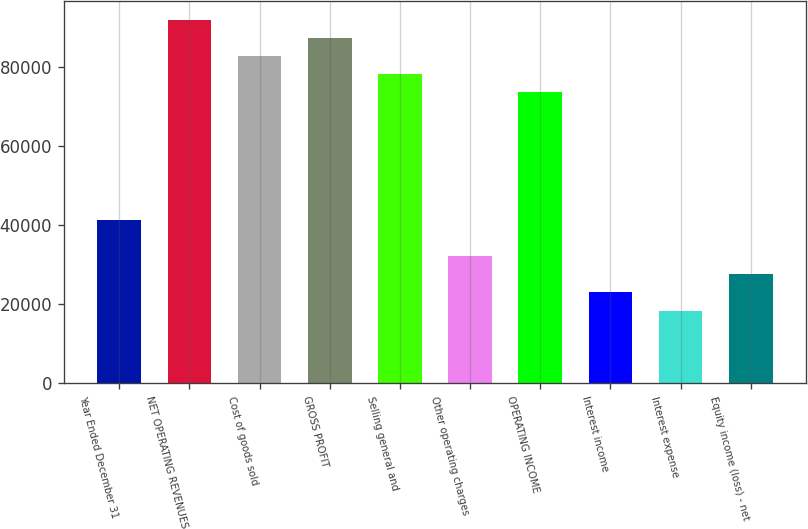<chart> <loc_0><loc_0><loc_500><loc_500><bar_chart><fcel>Year Ended December 31<fcel>NET OPERATING REVENUES<fcel>Cost of goods sold<fcel>GROSS PROFIT<fcel>Selling general and<fcel>Other operating charges<fcel>OPERATING INCOME<fcel>Interest income<fcel>Interest expense<fcel>Equity income (loss) - net<nl><fcel>41398.4<fcel>91994.4<fcel>82795.1<fcel>87394.8<fcel>78195.5<fcel>32199.1<fcel>73595.8<fcel>22999.8<fcel>18400.2<fcel>27599.4<nl></chart> 